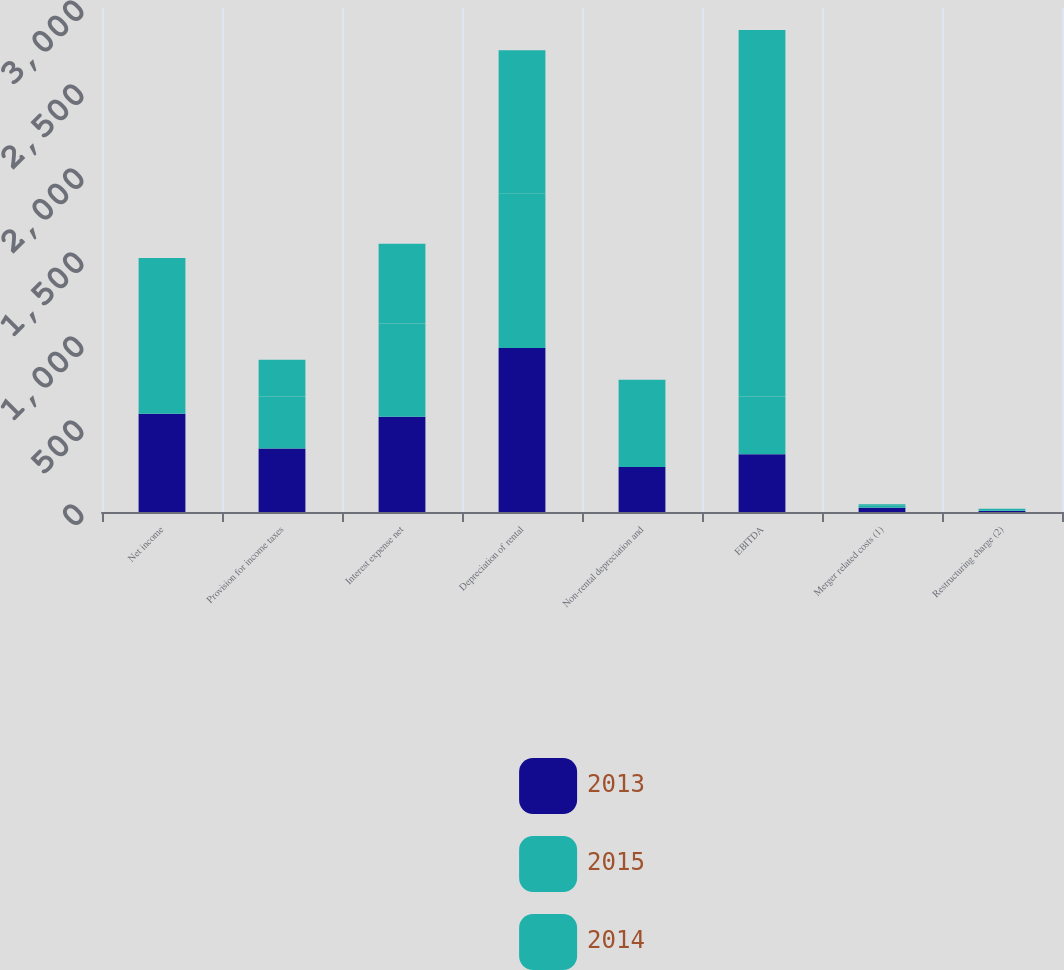Convert chart. <chart><loc_0><loc_0><loc_500><loc_500><stacked_bar_chart><ecel><fcel>Net income<fcel>Provision for income taxes<fcel>Interest expense net<fcel>Depreciation of rental<fcel>Non-rental depreciation and<fcel>EBITDA<fcel>Merger related costs (1)<fcel>Restructuring charge (2)<nl><fcel>2013<fcel>585<fcel>378<fcel>567<fcel>976<fcel>268<fcel>344<fcel>26<fcel>6<nl><fcel>2015<fcel>540<fcel>310<fcel>555<fcel>921<fcel>273<fcel>344<fcel>11<fcel>1<nl><fcel>2014<fcel>387<fcel>218<fcel>475<fcel>852<fcel>246<fcel>2181<fcel>9<fcel>12<nl></chart> 